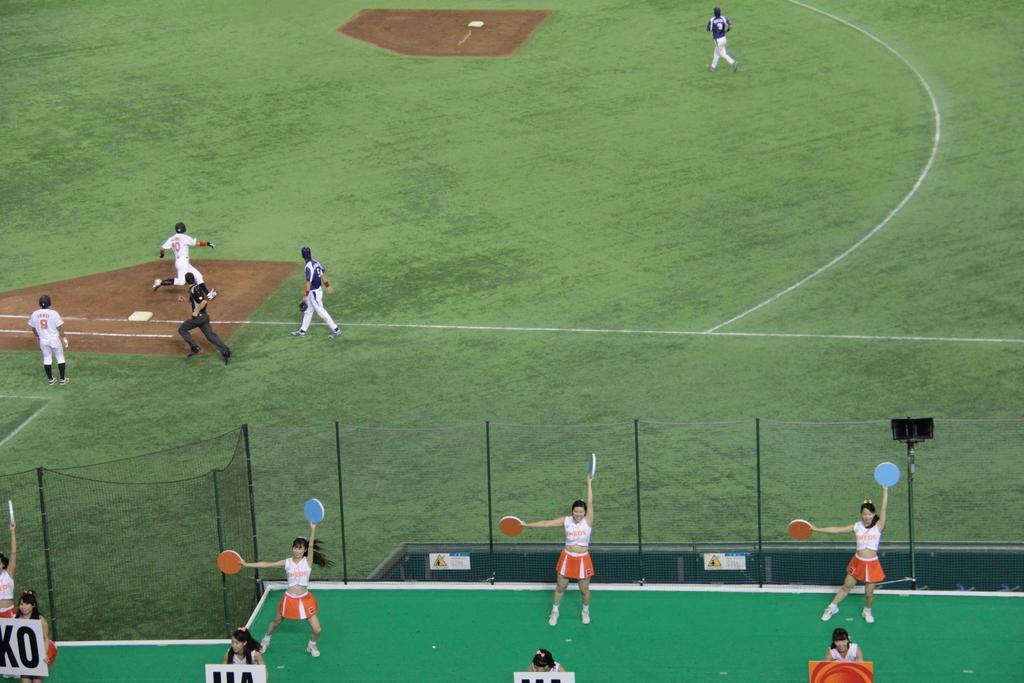How would you summarize this image in a sentence or two? In the foreground of the image we can see group of women standing on the ground holding a board in their hand. In the center of the image we can see a group of people wearing dress are standing on the ground. In the background, we can see a fence. 